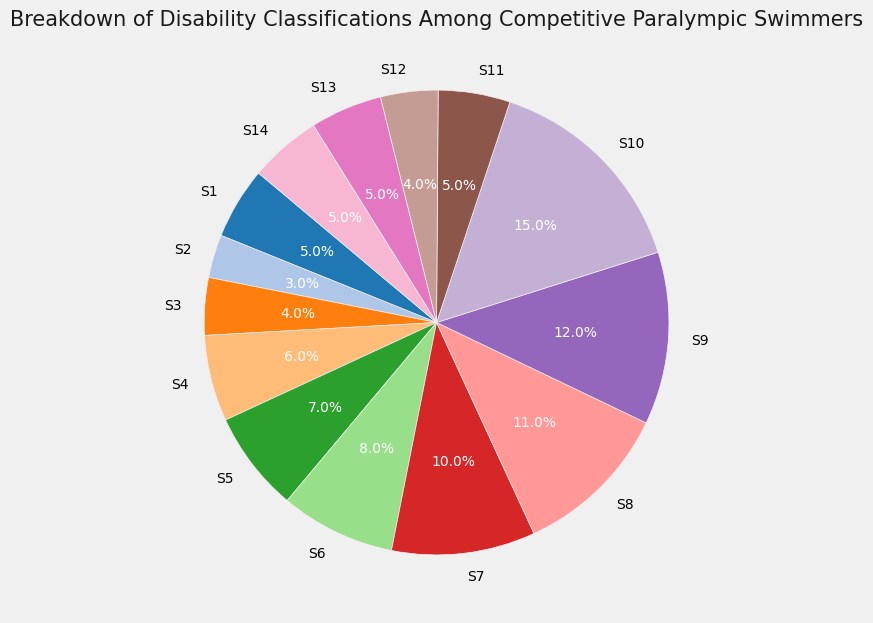What is the most common disability classification among competitive Paralympic swimmers? The largest section of the pie chart represents 15%, which corresponds to S10. Therefore, S10 is the most common disability classification.
Answer: S10 Which disability classifications have the same percentage representation? By examining the pie chart, the segments for S1, S11, S13, and S14 all show 5%, indicating they have the same percentage representation.
Answer: S1, S11, S13, S14 What percentage of competitive Paralympic swimmers fall under classifications S1 through S5? Sum the percentages for S1 (5%), S2 (3%), S3 (4%), S4 (6%), and S5 (7%): 5 + 3 + 4 + 6 + 7 = 25%.
Answer: 25% Which classifications have a lower percentage than S9? S9 has a percentage of 12%. The classifications with lower percentages are S1 (5%), S2 (3%), S3 (4%), S4 (6%), S5 (7%), S6 (8%), S7 (10%), S11 (5%), S12 (4%), S13 (5%), S14 (5%).
Answer: S1, S2, S3, S4, S5, S6, S7, S11, S12, S13, S14 What is the combined percentage of classifications S7 and S8? Adding the percentages for S7 (10%) and S8 (11%) gives 10 + 11 = 21%.
Answer: 21% Which classification has exactly half the representation compared to S10? S10 is represented by 15%. The percentage half of 15% is 7.5%. No classifications have exactly 7.5%, but the closest is S5 with 7%.
Answer: S5 Among classifications S11 to S14, which has the lowest percentage? S11, S12, S13, and S14 have percentages of 5%, 4%, 5%, and 5%, respectively. S12 has the lowest percentage at 4%.
Answer: S12 What is the median percentage of all disability classifications presented? To find the median, list all percentages in ascending order (3, 4, 4, 5, 5, 5, 5, 6, 7, 8, 10, 11, 12, 15). The middle values are 5% and 6%, and their average is (5 + 6) / 2 = 5.5%.
Answer: 5.5% Are there more classifications above or below 10%? Classifications above 10% are S8 (11%), S9 (12%), S10 (15%)—3 classifications. Classifications below 10% are S1 (5%), S2 (3%), S3 (4%), S4 (6%), S5 (7%), S6 (8%), S7 (10%), S11 (5%), S12 (4%), S13 (5%), S14 (5%)—11 classifications. Therefore, more classifications are below 10%.
Answer: Below If you combine the percentages of the two least common classifications, what is their total? The least common classifications are S2 (3%) and S3 (4%). Adding their percentages gives 3 + 4 = 7%.
Answer: 7% 